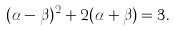<formula> <loc_0><loc_0><loc_500><loc_500>( \alpha - \beta ) ^ { 2 } + 2 ( \alpha + \beta ) = 3 .</formula> 